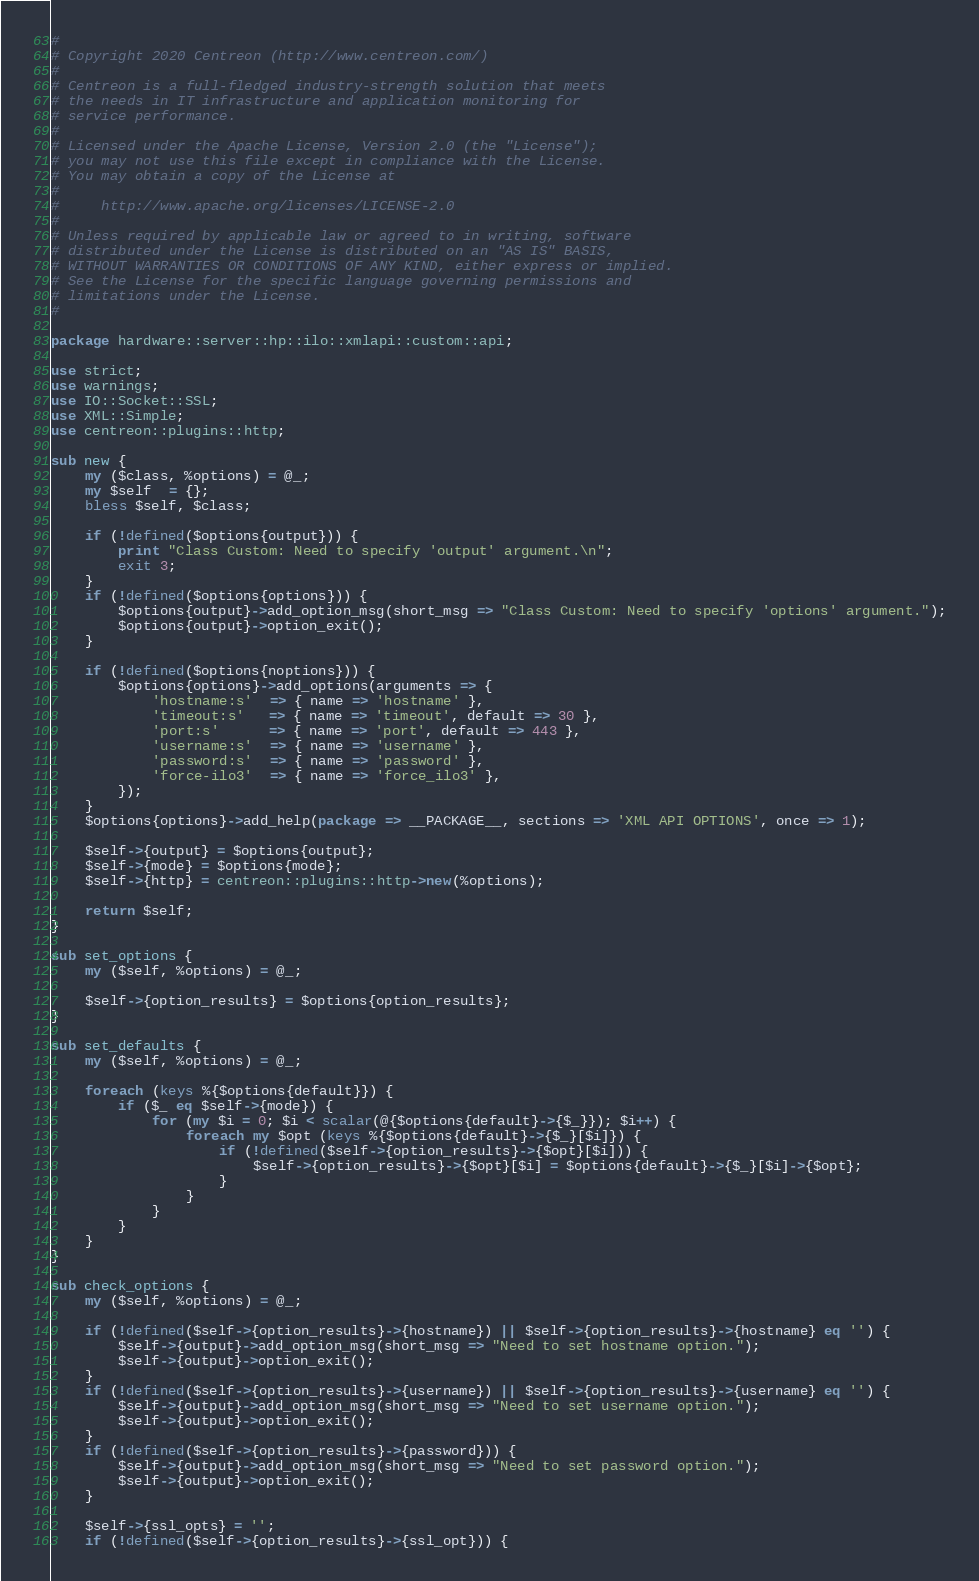<code> <loc_0><loc_0><loc_500><loc_500><_Perl_>#
# Copyright 2020 Centreon (http://www.centreon.com/)
#
# Centreon is a full-fledged industry-strength solution that meets
# the needs in IT infrastructure and application monitoring for
# service performance.
#
# Licensed under the Apache License, Version 2.0 (the "License");
# you may not use this file except in compliance with the License.
# You may obtain a copy of the License at
#
#     http://www.apache.org/licenses/LICENSE-2.0
#
# Unless required by applicable law or agreed to in writing, software
# distributed under the License is distributed on an "AS IS" BASIS,
# WITHOUT WARRANTIES OR CONDITIONS OF ANY KIND, either express or implied.
# See the License for the specific language governing permissions and
# limitations under the License.
#

package hardware::server::hp::ilo::xmlapi::custom::api;

use strict;
use warnings;
use IO::Socket::SSL;
use XML::Simple;
use centreon::plugins::http;

sub new {
    my ($class, %options) = @_;
    my $self  = {};
    bless $self, $class;

    if (!defined($options{output})) {
        print "Class Custom: Need to specify 'output' argument.\n";
        exit 3;
    }
    if (!defined($options{options})) {
        $options{output}->add_option_msg(short_msg => "Class Custom: Need to specify 'options' argument.");
        $options{output}->option_exit();
    }
    
    if (!defined($options{noptions})) {
        $options{options}->add_options(arguments => {                      
            'hostname:s'  => { name => 'hostname' },
            'timeout:s'   => { name => 'timeout', default => 30 },
            'port:s'      => { name => 'port', default => 443 },
            'username:s'  => { name => 'username' },
            'password:s'  => { name => 'password' },
            'force-ilo3'  => { name => 'force_ilo3' },
        });
    }
    $options{options}->add_help(package => __PACKAGE__, sections => 'XML API OPTIONS', once => 1);

    $self->{output} = $options{output};
    $self->{mode} = $options{mode};
    $self->{http} = centreon::plugins::http->new(%options);
    
    return $self;
}

sub set_options {
    my ($self, %options) = @_;

    $self->{option_results} = $options{option_results};
}

sub set_defaults {
    my ($self, %options) = @_;

    foreach (keys %{$options{default}}) {
        if ($_ eq $self->{mode}) {
            for (my $i = 0; $i < scalar(@{$options{default}->{$_}}); $i++) {
                foreach my $opt (keys %{$options{default}->{$_}[$i]}) {
                    if (!defined($self->{option_results}->{$opt}[$i])) {
                        $self->{option_results}->{$opt}[$i] = $options{default}->{$_}[$i]->{$opt};
                    }
                }
            }
        }
    }
}

sub check_options {
    my ($self, %options) = @_;

    if (!defined($self->{option_results}->{hostname}) || $self->{option_results}->{hostname} eq '') {
        $self->{output}->add_option_msg(short_msg => "Need to set hostname option.");
        $self->{output}->option_exit();
    }
    if (!defined($self->{option_results}->{username}) || $self->{option_results}->{username} eq '') {
        $self->{output}->add_option_msg(short_msg => "Need to set username option.");
        $self->{output}->option_exit();
    }
    if (!defined($self->{option_results}->{password})) {
        $self->{output}->add_option_msg(short_msg => "Need to set password option.");
        $self->{output}->option_exit();
    }
 
    $self->{ssl_opts} = '';
    if (!defined($self->{option_results}->{ssl_opt})) {</code> 